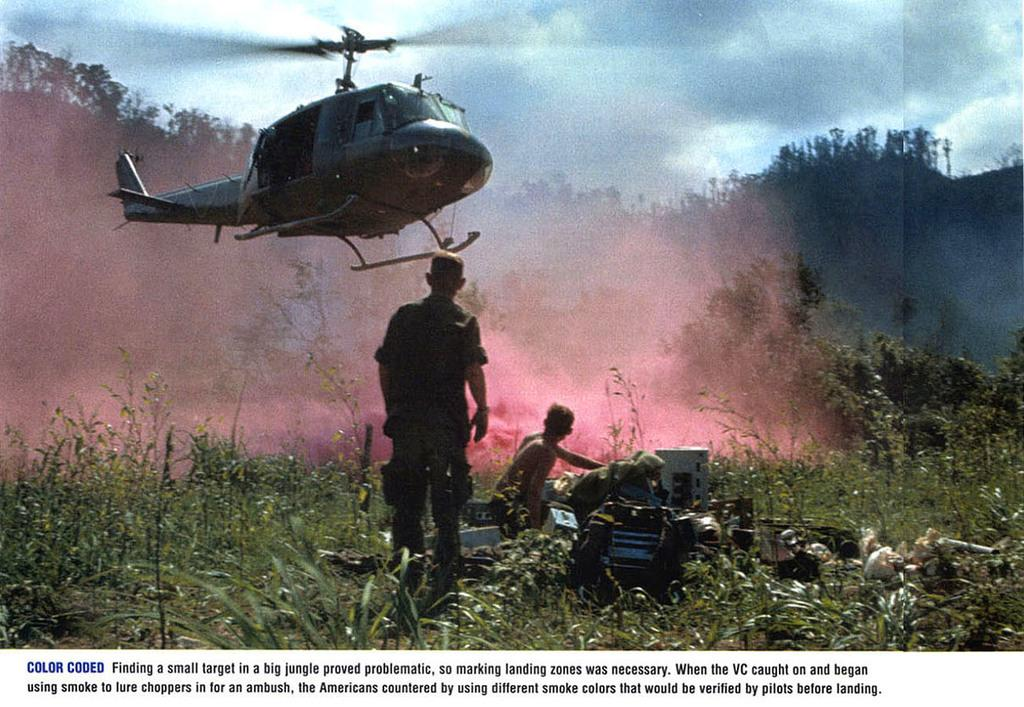Provide a one-sentence caption for the provided image. A photograph documenting a moment from the Vietnam War is titled Color Coded. 